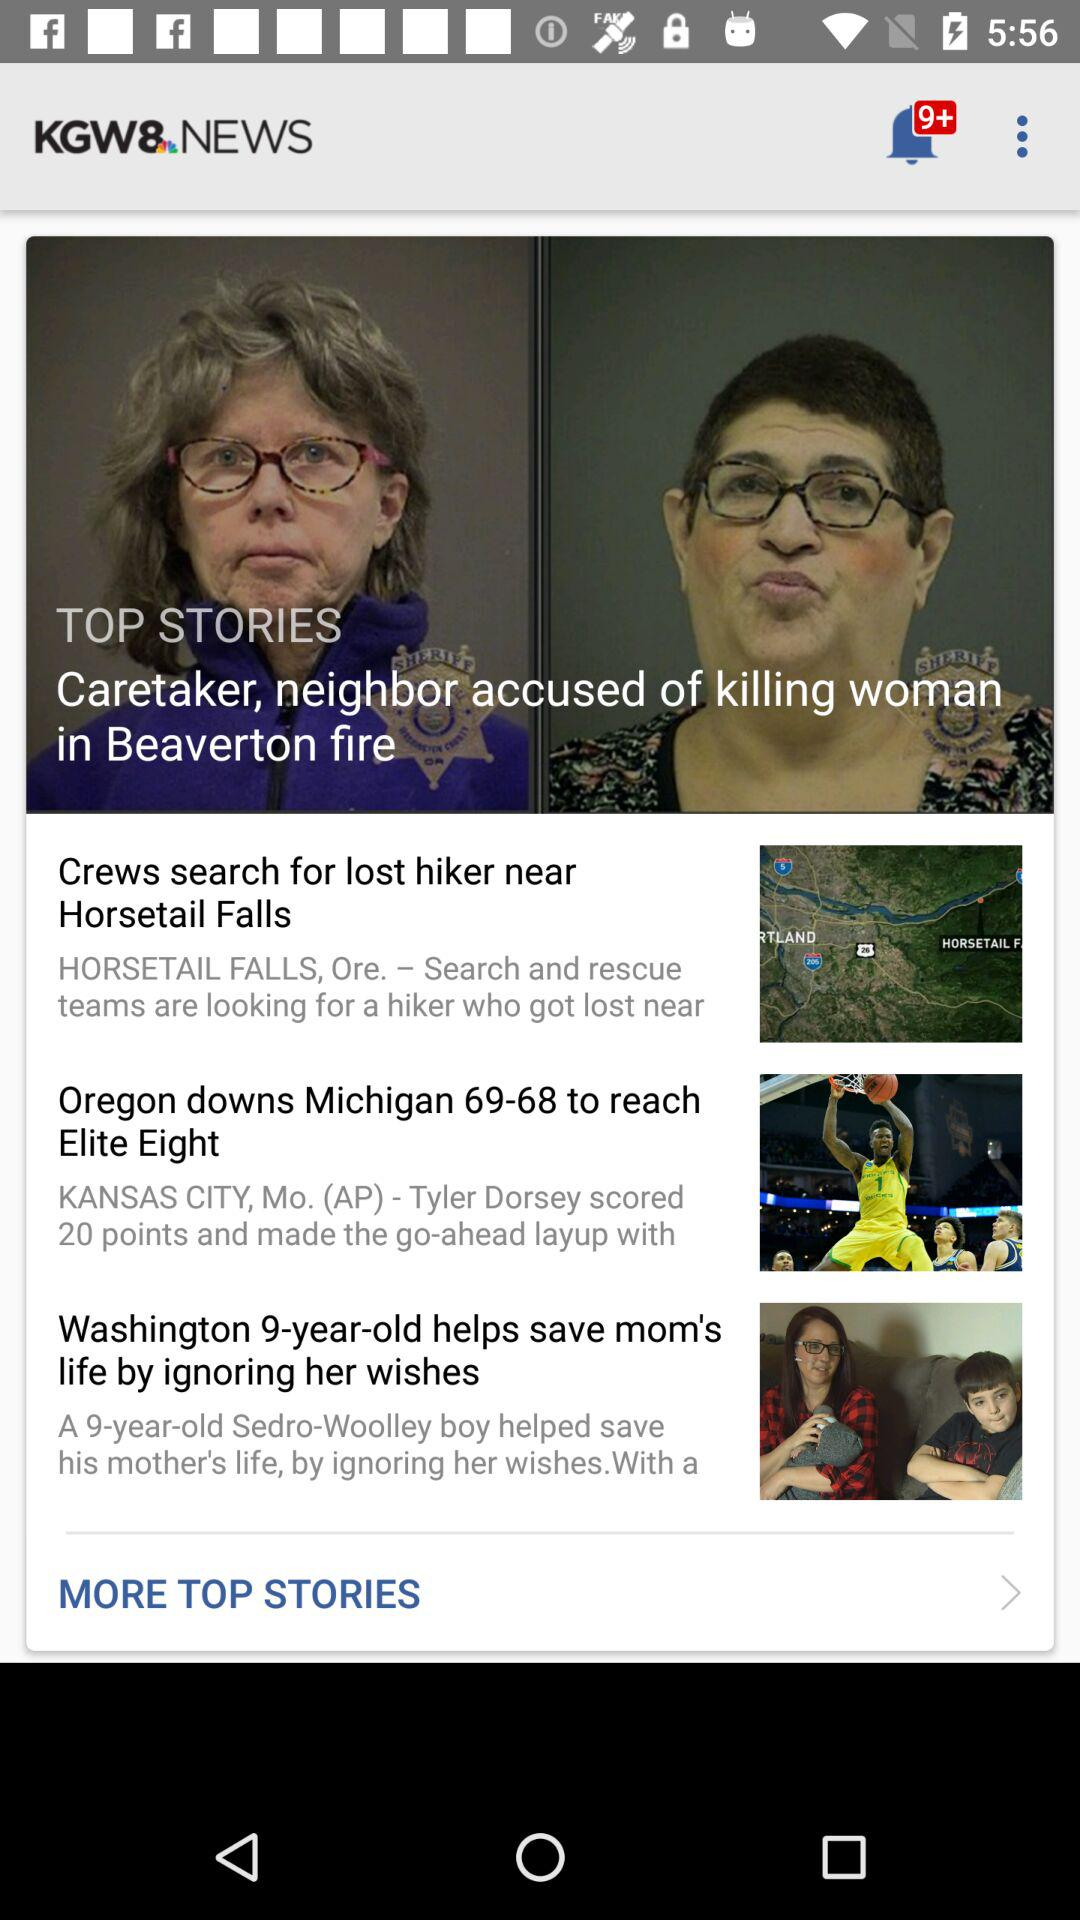What is the number of new notifications? The number of new notifications is more than 9. 